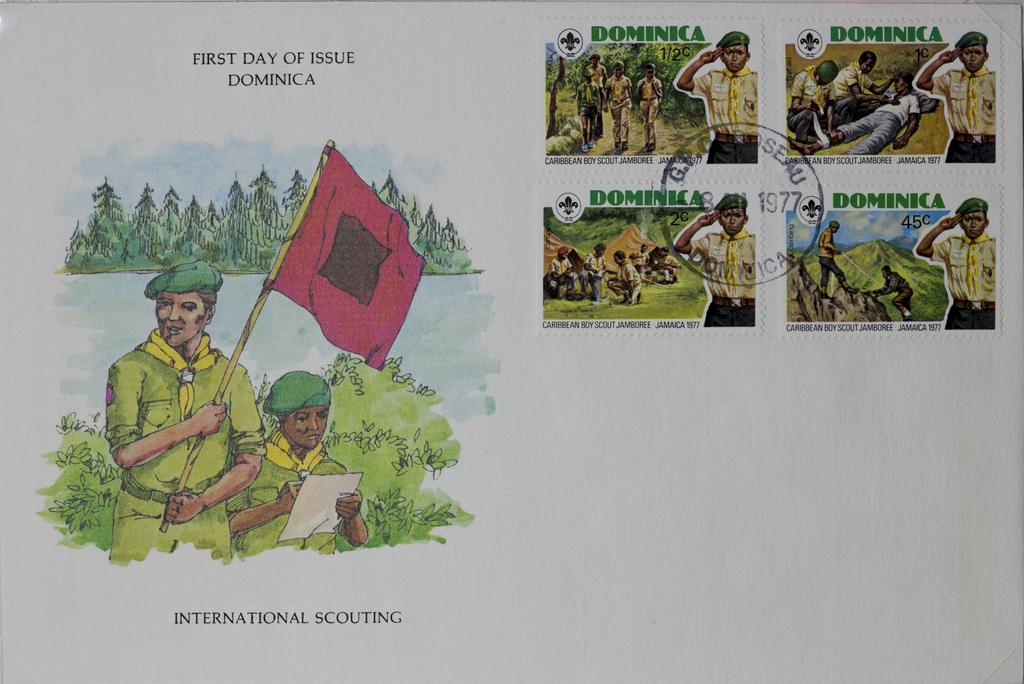<image>
Offer a succinct explanation of the picture presented. Picture showing a two boys and one holding a red flag with the words "First day of issue DOminica" on top. 